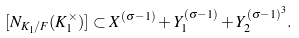Convert formula to latex. <formula><loc_0><loc_0><loc_500><loc_500>[ N _ { K _ { 1 } / F } ( K _ { 1 } ^ { \times } ) ] \subset X ^ { ( \sigma - 1 ) } + Y _ { 1 } ^ { ( \sigma - 1 ) } + Y _ { 2 } ^ { ( \sigma - 1 ) ^ { 3 } } .</formula> 